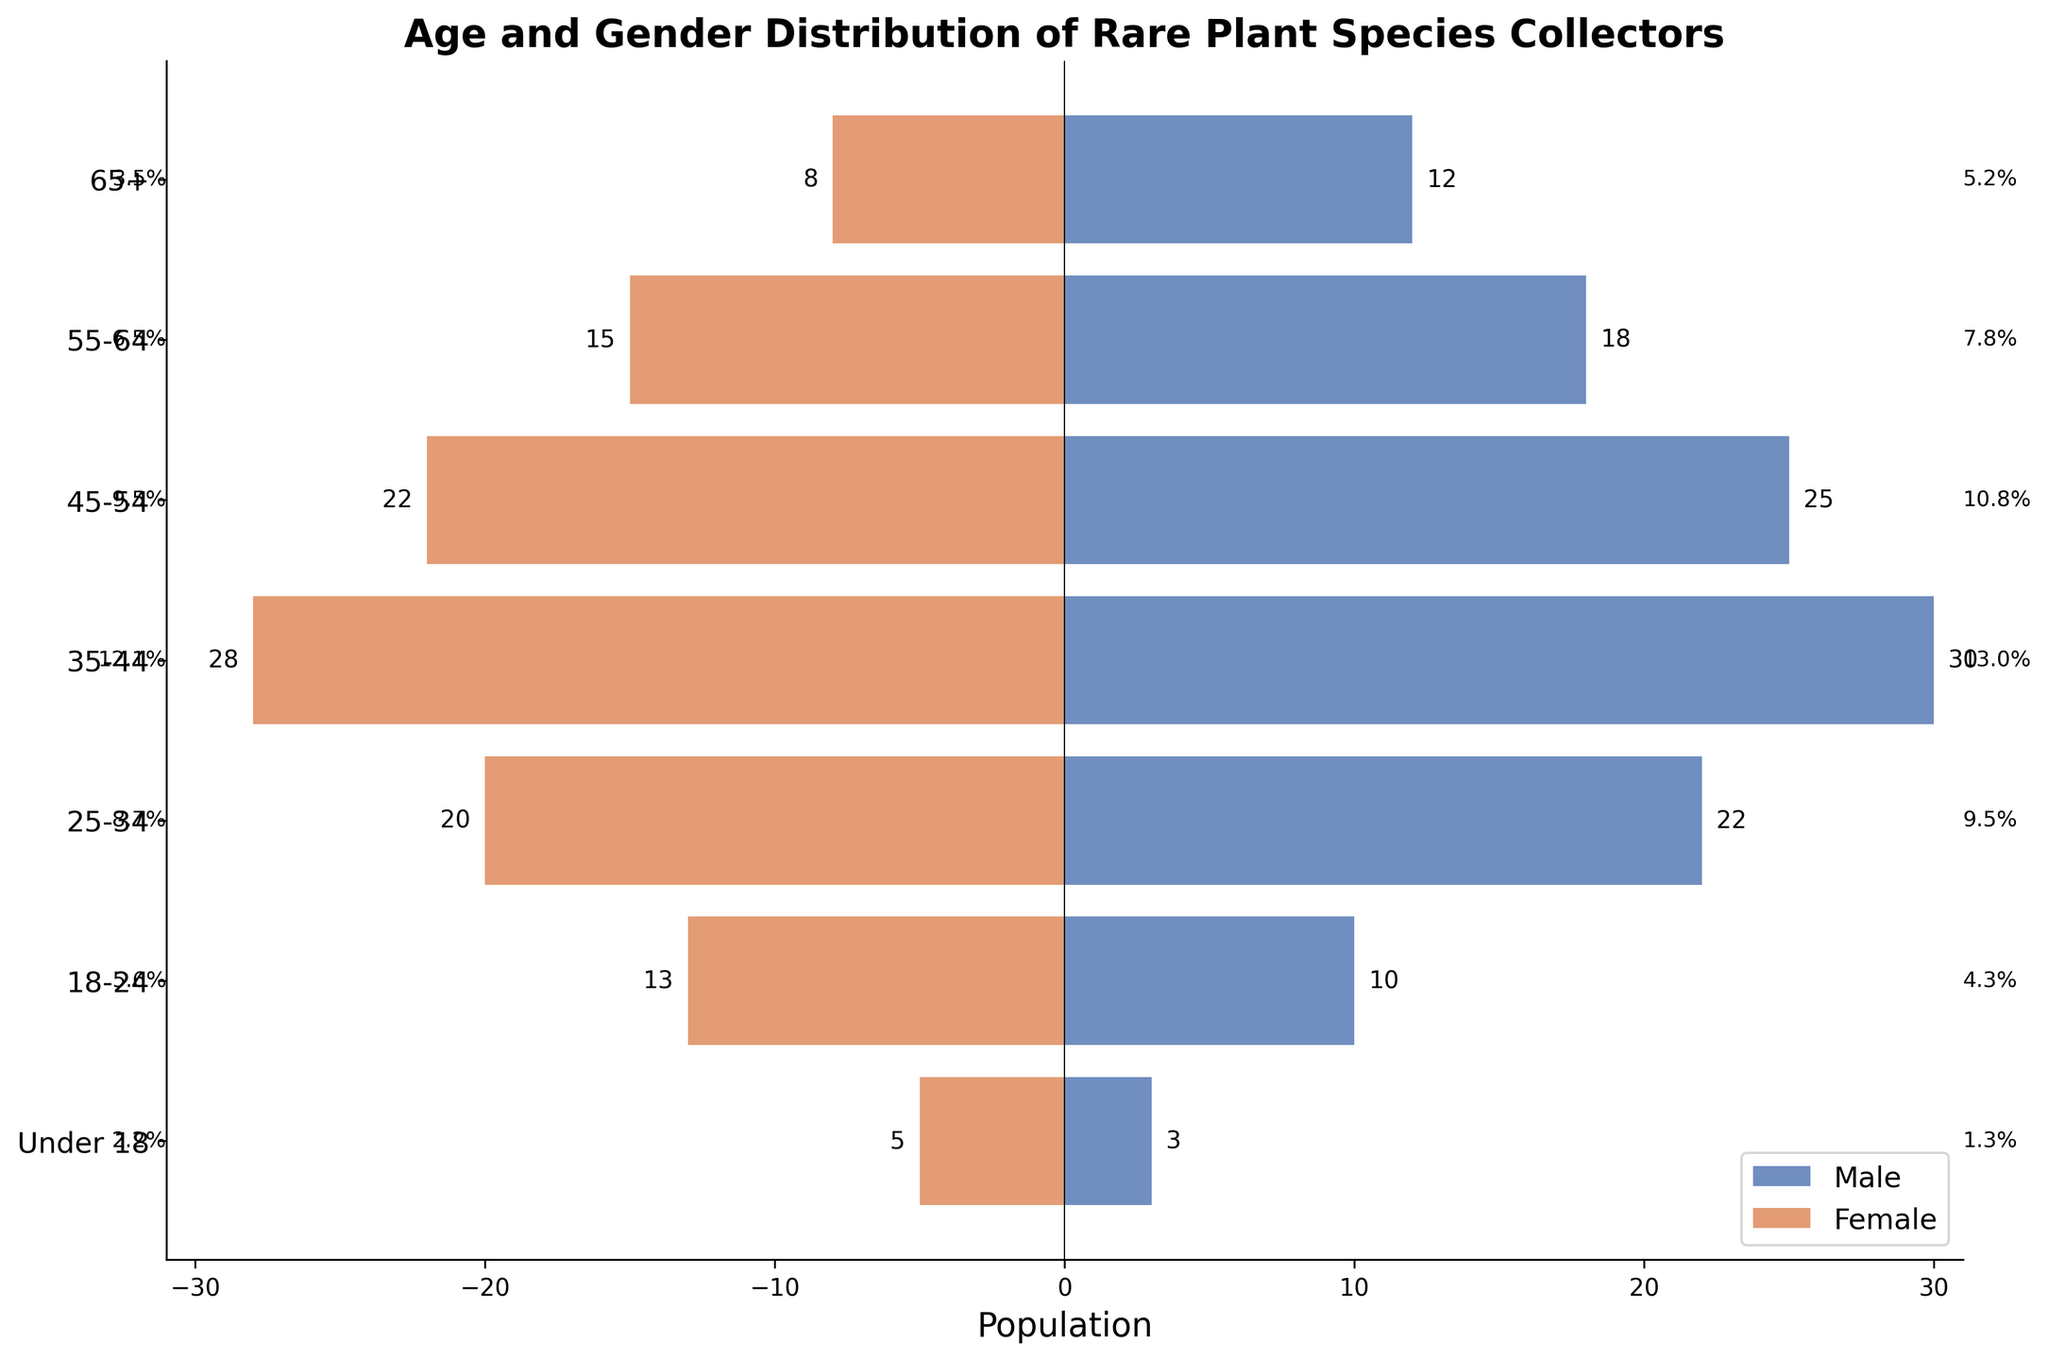What is the title of the figure? The title of the figure is displayed at the top of the chart, usually in bold text.
Answer: Age and Gender Distribution of Rare Plant Species Collectors What age group has the highest number of male collectors? To find the age group with the highest number of male collectors, look for the longest blue bar.
Answer: 35-44 How many female collectors are in the 18-24 age group? Locate the 18-24 age group on the vertical axis and look at the length of the red bar. Read the value next to this bar.
Answer: 13 What is the total number of collectors in the 65+ age group? Sum the number of male and female collectors in the 65+ age group.
Answer: 20 Which age group has more female than male collectors? Compare the length of the blue and red bars for each age group to see where the red bar is longer.
Answer: 18-24 What is the percentage of male collectors in the 45-54 age group? Calculate the total collectors in the 45-54 group, then find the proportion of males and multiply by 100. (25 / (25 + 22)) * 100 = 53.2%
Answer: 53.2% Compare the number of male and female collectors in the 55-64 age group. What is the difference? Subtract the number of female collectors from the number of male collectors in the 55-64 group (18 - 15).
Answer: 3 Which age group has the smallest total number of collectors? Find the age group with the shortest combined length of the blue and red bars by adding their values.
Answer: Under 18 How does the number of male collectors in the 35-44 age group compare to the number in the 25-34 age group? Compare the lengths of the blue bars for these two age groups.
Answer: 35-44 age group has more male collectors than the 25-34 age group What is the average number of female collectors across all age groups? Add up the number of female collectors in all age groups and divide by the number of age groups. (8 + 15 + 22 + 28 + 20 + 13 + 5) / 7 = 111 / 7 = 15.9
Answer: 15.9 